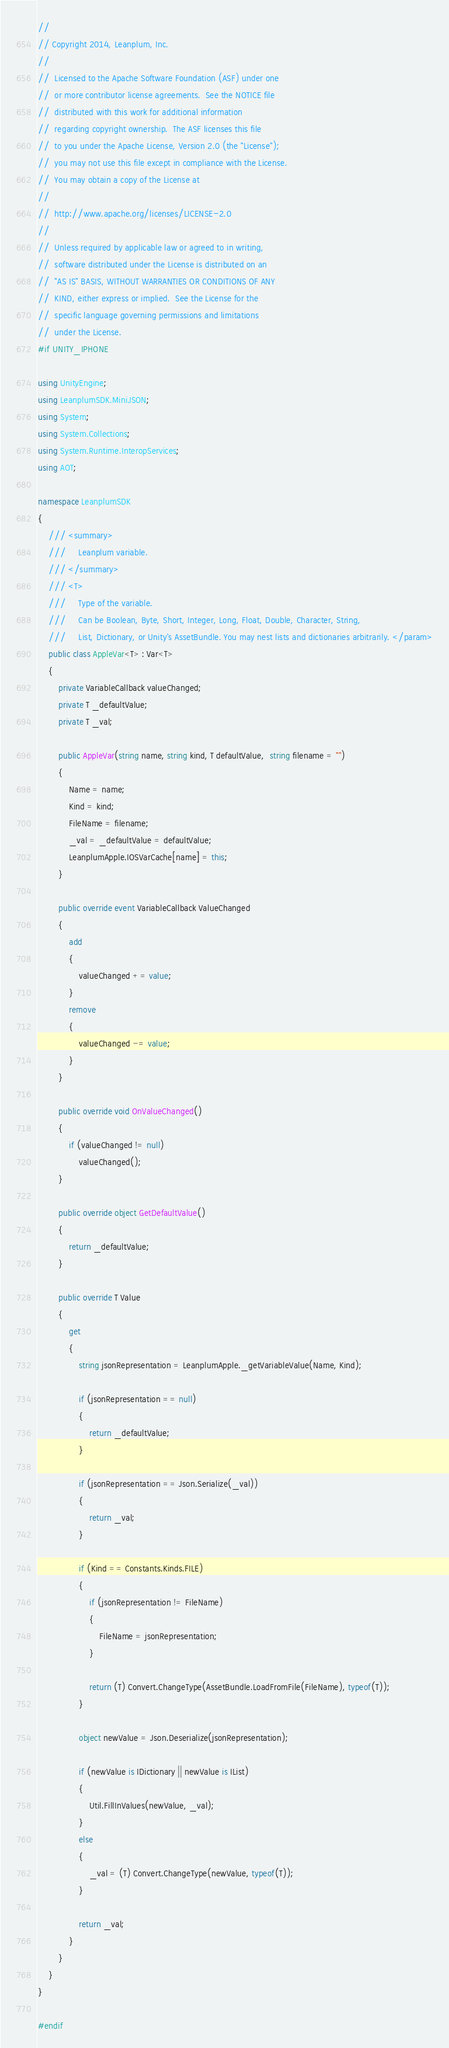<code> <loc_0><loc_0><loc_500><loc_500><_C#_>//
// Copyright 2014, Leanplum, Inc.
//
//  Licensed to the Apache Software Foundation (ASF) under one
//  or more contributor license agreements.  See the NOTICE file
//  distributed with this work for additional information
//  regarding copyright ownership.  The ASF licenses this file
//  to you under the Apache License, Version 2.0 (the "License");
//  you may not use this file except in compliance with the License.
//  You may obtain a copy of the License at
//
//  http://www.apache.org/licenses/LICENSE-2.0
//
//  Unless required by applicable law or agreed to in writing,
//  software distributed under the License is distributed on an
//  "AS IS" BASIS, WITHOUT WARRANTIES OR CONDITIONS OF ANY
//  KIND, either express or implied.  See the License for the
//  specific language governing permissions and limitations
//  under the License.
#if UNITY_IPHONE

using UnityEngine;
using LeanplumSDK.MiniJSON;
using System;
using System.Collections;
using System.Runtime.InteropServices;
using AOT;

namespace LeanplumSDK
{
	/// <summary>
	///     Leanplum variable.
	/// </summary>
	/// <T>
	///     Type of the variable.
	///     Can be Boolean, Byte, Short, Integer, Long, Float, Double, Character, String,
	///     List, Dictionary, or Unity's AssetBundle. You may nest lists and dictionaries arbitrarily. </param>
	public class AppleVar<T> : Var<T>
	{
		private VariableCallback valueChanged;
		private T _defaultValue;
		private T _val;
		
		public AppleVar(string name, string kind, T defaultValue,  string filename = "")
		{
			Name = name;
			Kind = kind;
			FileName = filename;
			_val = _defaultValue = defaultValue;
			LeanplumApple.IOSVarCache[name] = this;
		}

		public override event VariableCallback ValueChanged
		{
			add
			{
				valueChanged += value;
			}
			remove
			{
				valueChanged -= value;
			}
		}

		public override void OnValueChanged()
		{
			if (valueChanged != null)
				valueChanged();
		}

		public override object GetDefaultValue()
		{
			return _defaultValue;
		}

		public override T Value
		{ 
			get
			{
				string jsonRepresentation = LeanplumApple._getVariableValue(Name, Kind);

				if (jsonRepresentation == null)
				{
					return _defaultValue;
				}

				if (jsonRepresentation == Json.Serialize(_val))
				{
					return _val;
				}

				if (Kind == Constants.Kinds.FILE)
				{
					if (jsonRepresentation != FileName)
					{
						FileName = jsonRepresentation;
					}
					
					return (T) Convert.ChangeType(AssetBundle.LoadFromFile(FileName), typeof(T));
				}

				object newValue = Json.Deserialize(jsonRepresentation);

				if (newValue is IDictionary || newValue is IList)
				{
					Util.FillInValues(newValue, _val);
				}
				else
				{
					_val = (T) Convert.ChangeType(newValue, typeof(T));
				}
				
				return _val;
			}
		}
	}
}

#endif
</code> 